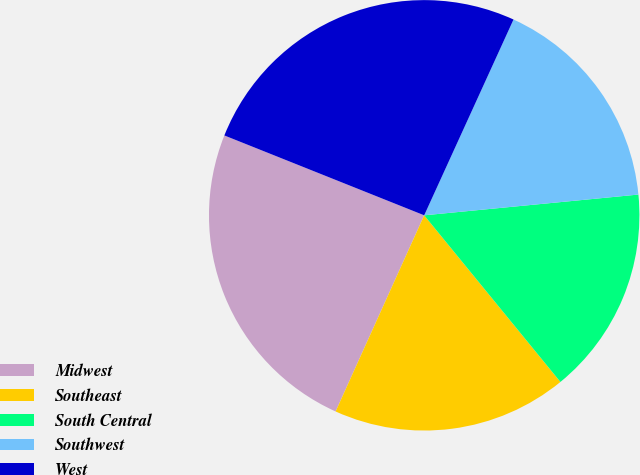<chart> <loc_0><loc_0><loc_500><loc_500><pie_chart><fcel>Midwest<fcel>Southeast<fcel>South Central<fcel>Southwest<fcel>West<nl><fcel>24.3%<fcel>17.66%<fcel>15.63%<fcel>16.65%<fcel>25.76%<nl></chart> 